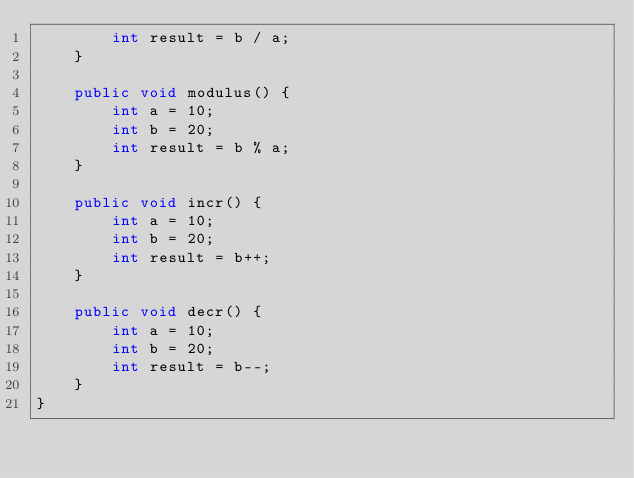Convert code to text. <code><loc_0><loc_0><loc_500><loc_500><_Java_>        int result = b / a;
    }

    public void modulus() {
        int a = 10;
        int b = 20;
        int result = b % a;
    }

    public void incr() {
        int a = 10;
        int b = 20;
        int result = b++;
    }

    public void decr() {
        int a = 10;
        int b = 20;
        int result = b--;
    }
}
</code> 